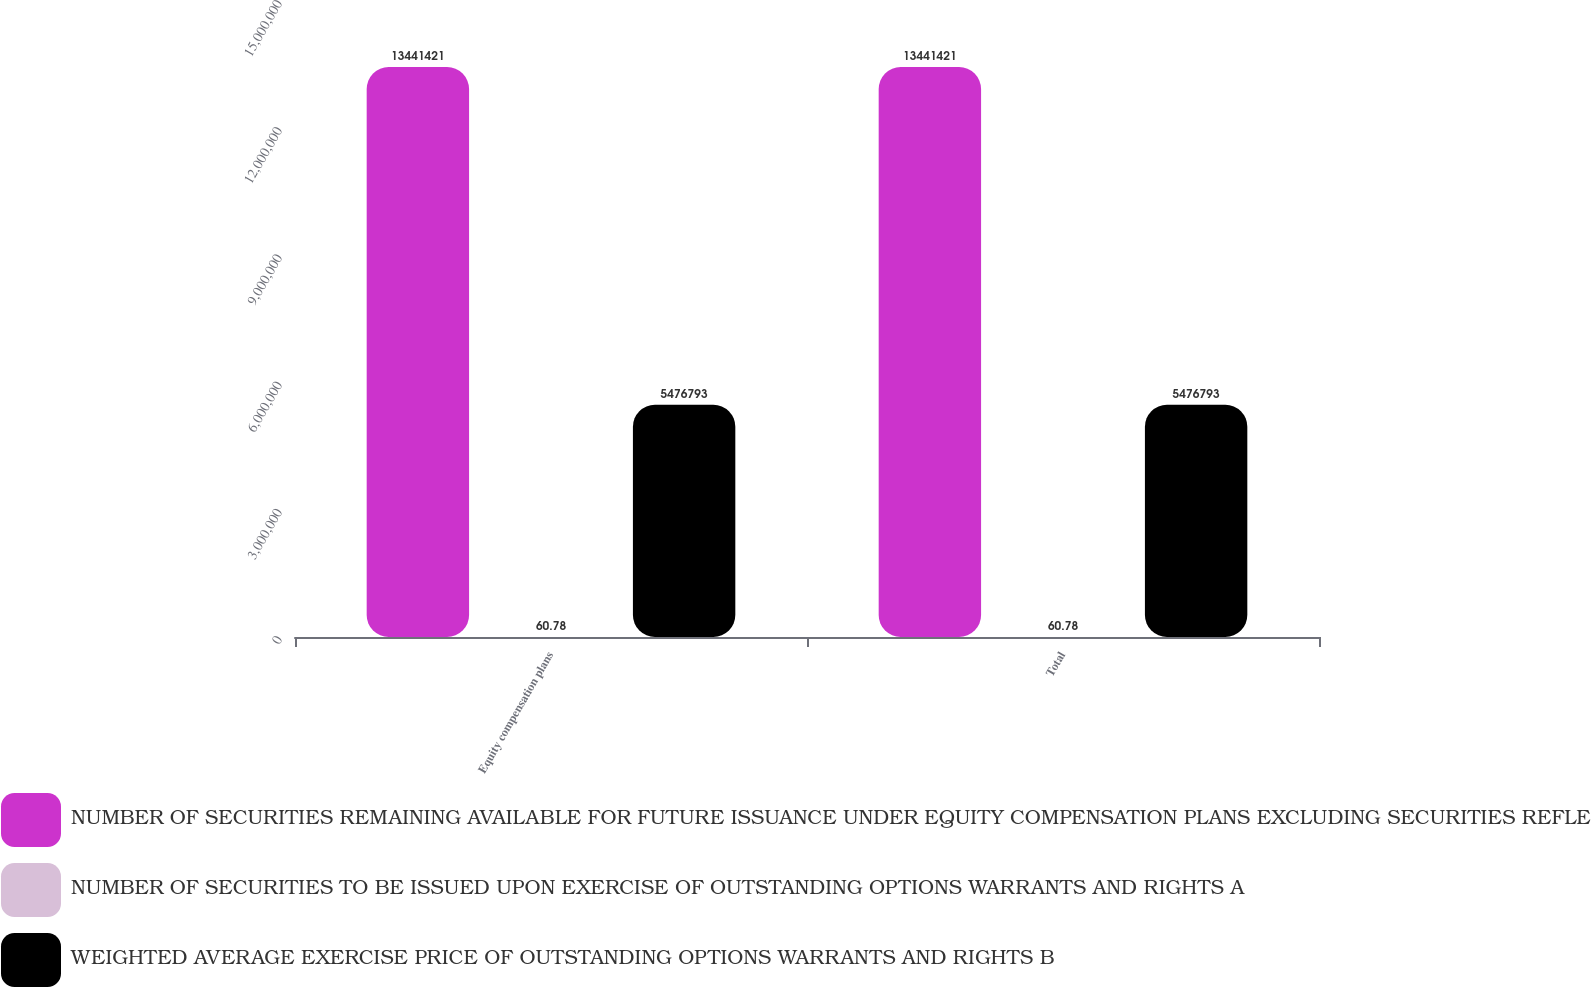<chart> <loc_0><loc_0><loc_500><loc_500><stacked_bar_chart><ecel><fcel>Equity compensation plans<fcel>Total<nl><fcel>NUMBER OF SECURITIES REMAINING AVAILABLE FOR FUTURE ISSUANCE UNDER EQUITY COMPENSATION PLANS EXCLUDING SECURITIES REFLECTED IN COLUMN A C<fcel>1.34414e+07<fcel>1.34414e+07<nl><fcel>NUMBER OF SECURITIES TO BE ISSUED UPON EXERCISE OF OUTSTANDING OPTIONS WARRANTS AND RIGHTS A<fcel>60.78<fcel>60.78<nl><fcel>WEIGHTED AVERAGE EXERCISE PRICE OF OUTSTANDING OPTIONS WARRANTS AND RIGHTS B<fcel>5.47679e+06<fcel>5.47679e+06<nl></chart> 